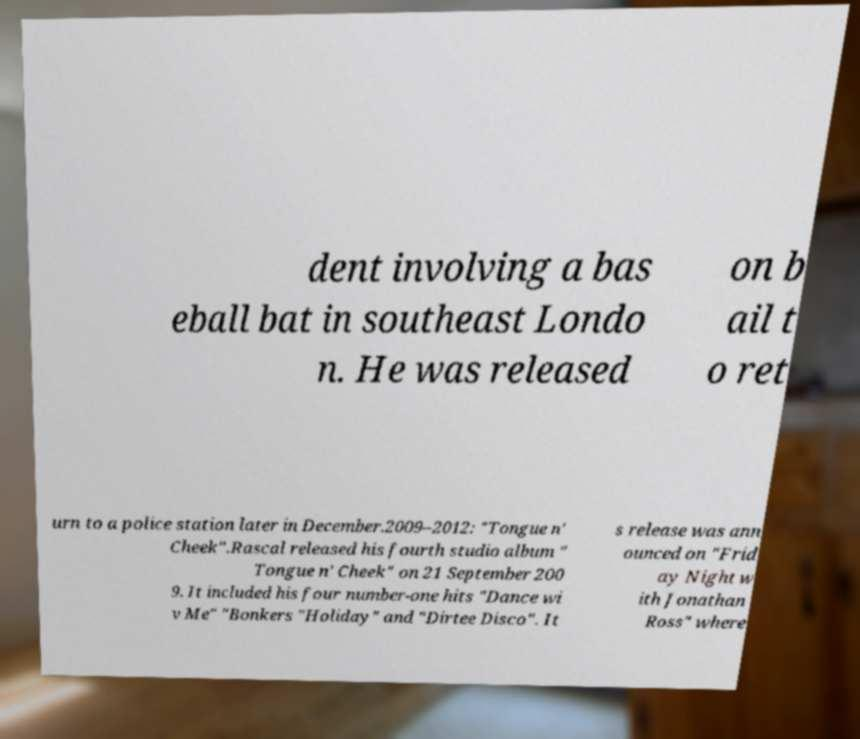Can you read and provide the text displayed in the image?This photo seems to have some interesting text. Can you extract and type it out for me? dent involving a bas eball bat in southeast Londo n. He was released on b ail t o ret urn to a police station later in December.2009–2012: "Tongue n' Cheek".Rascal released his fourth studio album " Tongue n' Cheek" on 21 September 200 9. It included his four number-one hits "Dance wi v Me" "Bonkers "Holiday" and "Dirtee Disco". It s release was ann ounced on "Frid ay Night w ith Jonathan Ross" where 